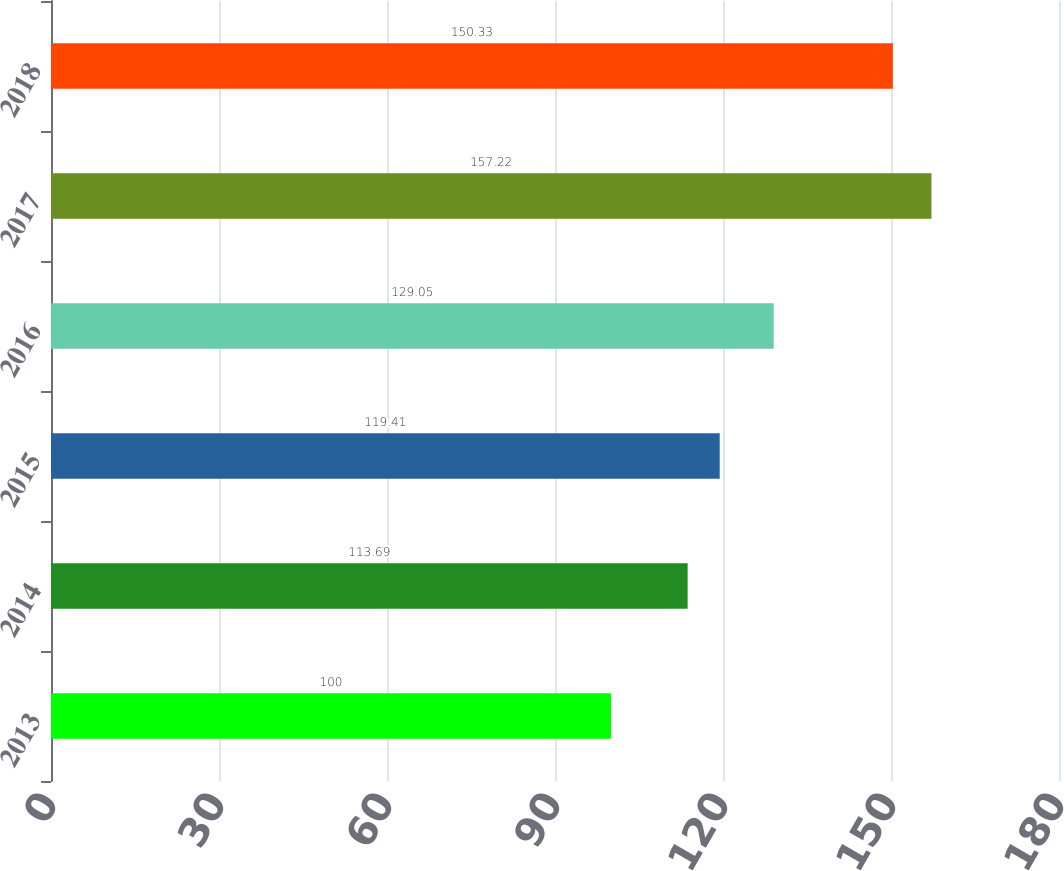<chart> <loc_0><loc_0><loc_500><loc_500><bar_chart><fcel>2013<fcel>2014<fcel>2015<fcel>2016<fcel>2017<fcel>2018<nl><fcel>100<fcel>113.69<fcel>119.41<fcel>129.05<fcel>157.22<fcel>150.33<nl></chart> 